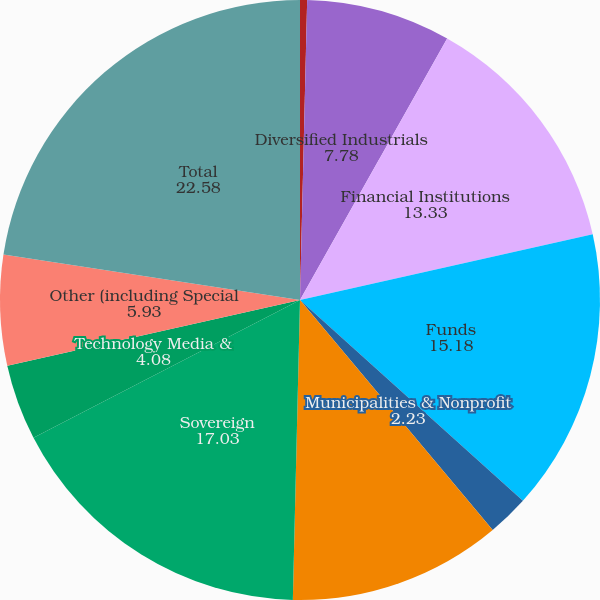<chart> <loc_0><loc_0><loc_500><loc_500><pie_chart><fcel>Consumer Retail & Healthcare<fcel>Diversified Industrials<fcel>Financial Institutions<fcel>Funds<fcel>Municipalities & Nonprofit<fcel>Natural Resources & Utilities<fcel>Sovereign<fcel>Technology Media &<fcel>Other (including Special<fcel>Total<nl><fcel>0.38%<fcel>7.78%<fcel>13.33%<fcel>15.18%<fcel>2.23%<fcel>11.48%<fcel>17.03%<fcel>4.08%<fcel>5.93%<fcel>22.58%<nl></chart> 